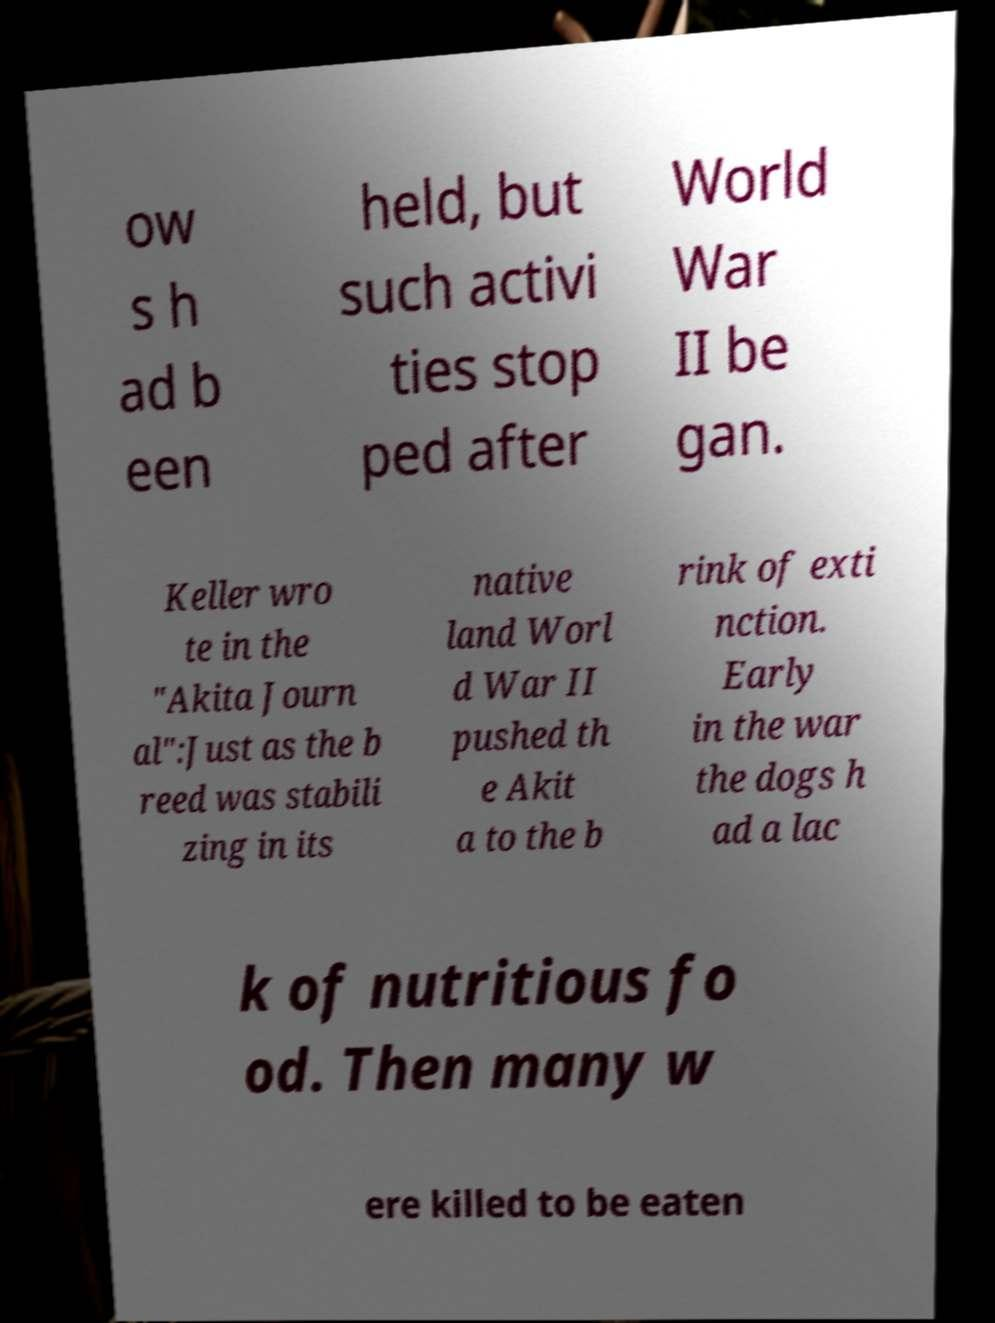Could you extract and type out the text from this image? ow s h ad b een held, but such activi ties stop ped after World War II be gan. Keller wro te in the "Akita Journ al":Just as the b reed was stabili zing in its native land Worl d War II pushed th e Akit a to the b rink of exti nction. Early in the war the dogs h ad a lac k of nutritious fo od. Then many w ere killed to be eaten 